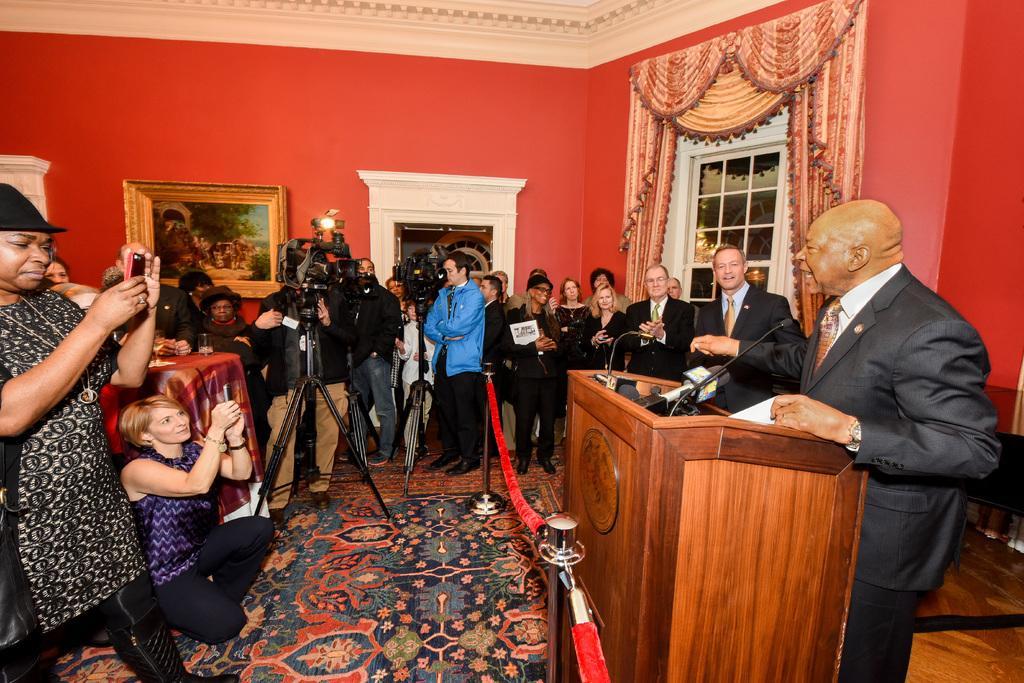Please provide a concise description of this image. In this picture there are people those who are standing in the center of the image and there is a man who is standing on the right side of the image and there is a mic and a desk in front of him and there is a window on the right side of the image, there is a portrait on the left side of the image. 